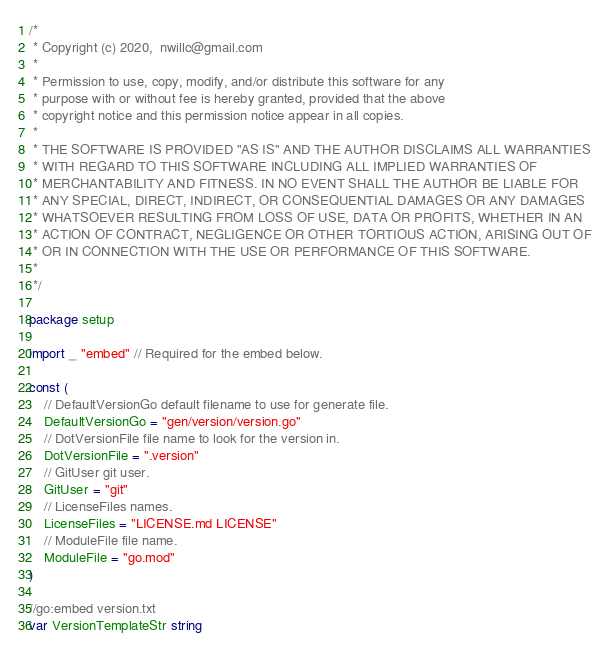Convert code to text. <code><loc_0><loc_0><loc_500><loc_500><_Go_>/*
 * Copyright (c) 2020,  nwillc@gmail.com
 *
 * Permission to use, copy, modify, and/or distribute this software for any
 * purpose with or without fee is hereby granted, provided that the above
 * copyright notice and this permission notice appear in all copies.
 *
 * THE SOFTWARE IS PROVIDED "AS IS" AND THE AUTHOR DISCLAIMS ALL WARRANTIES
 * WITH REGARD TO THIS SOFTWARE INCLUDING ALL IMPLIED WARRANTIES OF
 * MERCHANTABILITY AND FITNESS. IN NO EVENT SHALL THE AUTHOR BE LIABLE FOR
 * ANY SPECIAL, DIRECT, INDIRECT, OR CONSEQUENTIAL DAMAGES OR ANY DAMAGES
 * WHATSOEVER RESULTING FROM LOSS OF USE, DATA OR PROFITS, WHETHER IN AN
 * ACTION OF CONTRACT, NEGLIGENCE OR OTHER TORTIOUS ACTION, ARISING OUT OF
 * OR IN CONNECTION WITH THE USE OR PERFORMANCE OF THIS SOFTWARE.
 *
 */

package setup

import _ "embed" // Required for the embed below.

const (
	// DefaultVersionGo default filename to use for generate file.
	DefaultVersionGo = "gen/version/version.go"
	// DotVersionFile file name to look for the version in.
	DotVersionFile = ".version"
	// GitUser git user.
	GitUser = "git"
	// LicenseFiles names.
	LicenseFiles = "LICENSE.md LICENSE"
	// ModuleFile file name.
	ModuleFile = "go.mod"
)

//go:embed version.txt
var VersionTemplateStr string
</code> 